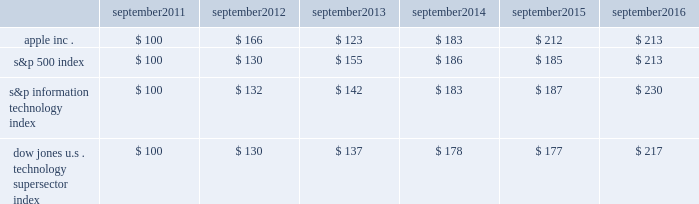Apple inc .
| 2016 form 10-k | 20 company stock performance the following graph shows a comparison of cumulative total shareholder return , calculated on a dividend reinvested basis , for the company , the s&p 500 index , the s&p information technology index and the dow jones u.s .
Technology supersector index for the five years ended september 24 , 2016 .
The graph assumes $ 100 was invested in each of the company 2019s common stock , the s&p 500 index , the s&p information technology index and the dow jones u.s .
Technology supersector index as of the market close on september 23 , 2011 .
Note that historic stock price performance is not necessarily indicative of future stock price performance .
* $ 100 invested on 9/23/11 in stock or index , including reinvestment of dividends .
Data points are the last day of each fiscal year for the company 2019s common stock and september 30th for indexes .
Copyright a9 2016 s&p , a division of mcgraw hill financial .
All rights reserved .
Copyright a9 2016 dow jones & co .
All rights reserved .
September september september september september september .

What was the cumulative change in the s&p 500 between 2016 and 2011? 
Computations: (213 - 100)
Answer: 113.0. 